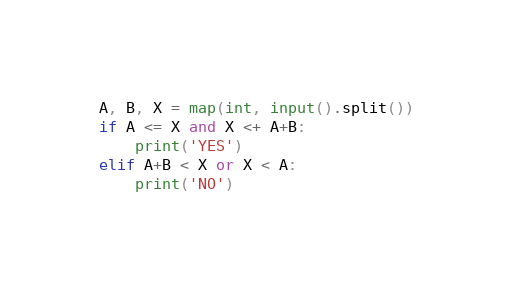<code> <loc_0><loc_0><loc_500><loc_500><_Python_>A, B, X = map(int, input().split())
if A <= X and X <+ A+B:
    print('YES')
elif A+B < X or X < A:
    print('NO')</code> 